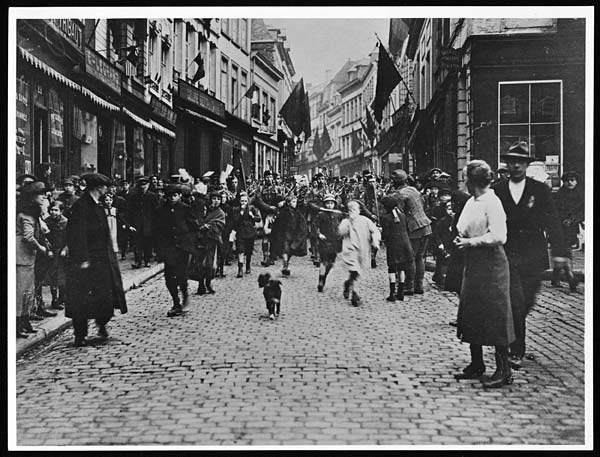Describe the objects in this image and their specific colors. I can see people in black, gray, darkgray, and lightgray tones, people in black, gray, lightgray, and darkgray tones, people in black, gray, darkgray, and lightgray tones, people in black, gray, darkgray, and lightgray tones, and people in black, gray, darkgray, and lightgray tones in this image. 